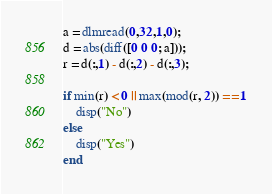<code> <loc_0><loc_0><loc_500><loc_500><_Octave_>a = dlmread(0,32,1,0);
d = abs(diff([0 0 0; a]));
r = d(:,1) - d(:,2) - d(:,3);

if min(r) < 0 || max(mod(r, 2)) == 1
    disp("No")
else
    disp("Yes")
end</code> 